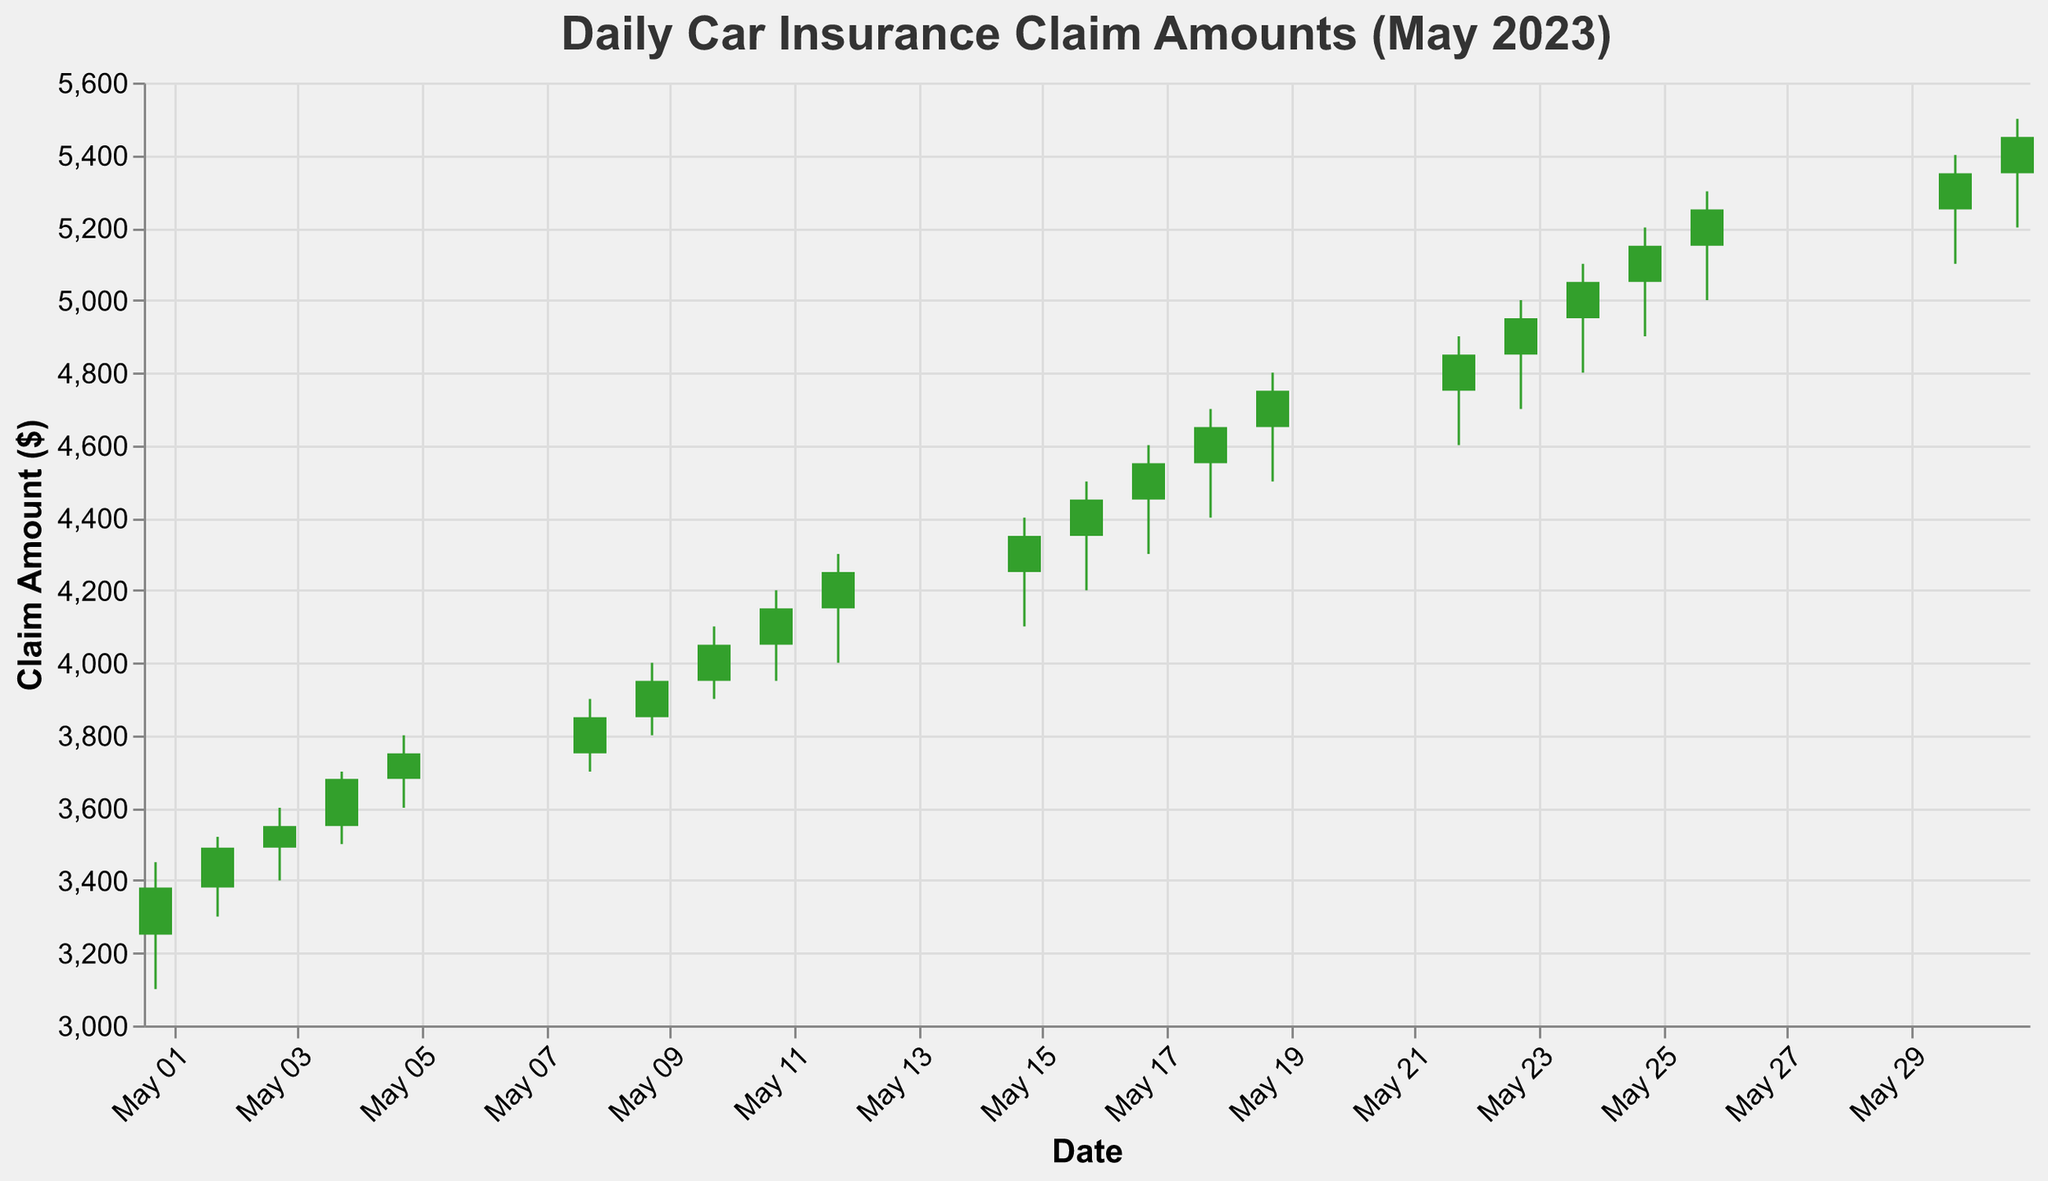What's the highest claim amount recorded in May 2023? The highest claim amount can be found by looking at the peaks (High values) for each date. The highest value is on May 31st with an amount of $5500.
Answer: $5500 On which day was the lowest claim amount of the month recorded? The lowest claim amount can be found by looking at the troughs (Low values) for each date. The lowest value is on May 1st with an amount of $3100.
Answer: May 1st What was the opening value on May 10th, and how does it compare to the closing value on the same day? The opening value on May 10th was $3950. The closing value on the same day was $4050. The closing value is $100 higher than the opening value.
Answer: Opening: $3950, Closing: $4050, Difference: $100 Which day saw the greatest difference between high and low claim amounts? To find the greatest difference between high and low claim amounts, calculate the difference (High - Low) for each date. The highest difference is seen on May 31st with a difference of $300.
Answer: May 31st How many days showed an increase in claim amounts from open to close? Count the days where the closing value is higher than the opening value. The days are May 1, May 2, May 3, May 4, May 5, May 8, May 9, May 10, May 11, May 12, May 15, May 16, May 17, May 18, May 19, May 22, May 23, May 24, May 25, May 26, May 30, and May 31. There are 22 days in total.
Answer: 22 days How much did the closing value change from May 15th to May 16th? The closing value on May 15th was $4350. On May 16th, it was $4450. The change in closing value is $4450 - $4350 = $100.
Answer: $100 Which day had the smallest range between the high and low claim amounts? Calculate the difference between high and low (High - Low) for each day. The smallest range is on May 4th with a difference of $200.
Answer: May 4th What was the average opening value for the first five days of May? Add the opening values of the first five days (3250, 3380, 3490, 3550, 3680) and divide by 5. The average is (3250 + 3380 + 3490 + 3550 + 3680)/5 = 3470.
Answer: $3470 How many days in May had a closing value above $5000? Count the days where the Closing value is greater than $5000. The days are May 24, May 25, May 26, May 30, and May 31, making it 5 days in total.
Answer: 5 days 